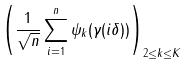Convert formula to latex. <formula><loc_0><loc_0><loc_500><loc_500>\left ( \frac { 1 } { \sqrt { n } } \sum _ { i = 1 } ^ { n } \psi _ { k } ( \gamma ( i \delta ) ) \right ) _ { 2 \leq k \leq K }</formula> 